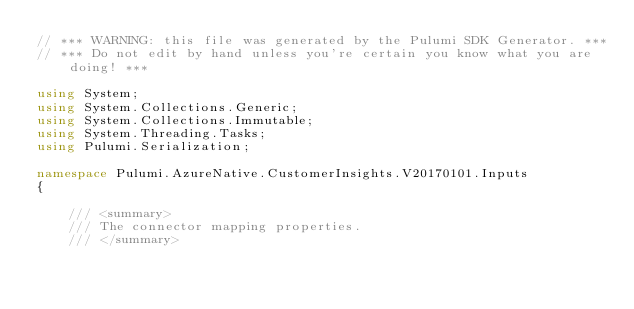<code> <loc_0><loc_0><loc_500><loc_500><_C#_>// *** WARNING: this file was generated by the Pulumi SDK Generator. ***
// *** Do not edit by hand unless you're certain you know what you are doing! ***

using System;
using System.Collections.Generic;
using System.Collections.Immutable;
using System.Threading.Tasks;
using Pulumi.Serialization;

namespace Pulumi.AzureNative.CustomerInsights.V20170101.Inputs
{

    /// <summary>
    /// The connector mapping properties.
    /// </summary></code> 